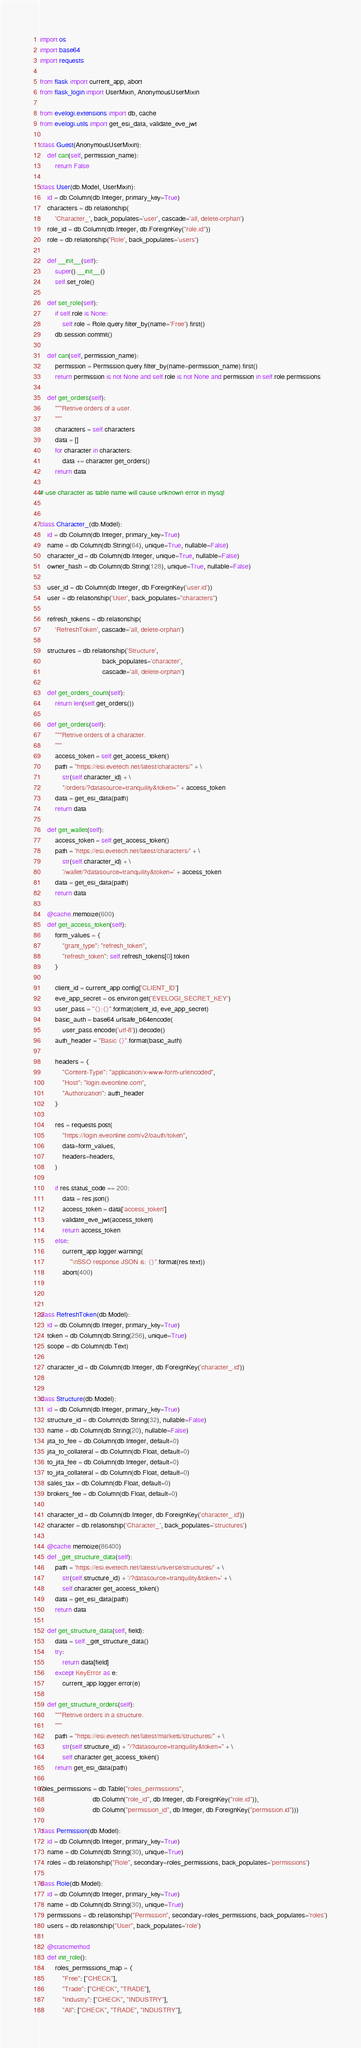Convert code to text. <code><loc_0><loc_0><loc_500><loc_500><_Python_>import os
import base64
import requests

from flask import current_app, abort
from flask_login import UserMixin, AnonymousUserMixin

from evelogi.extensions import db, cache
from evelogi.utils import get_esi_data, validate_eve_jwt

class Guest(AnonymousUserMixin):
    def can(self, permission_name):
        return False

class User(db.Model, UserMixin):
    id = db.Column(db.Integer, primary_key=True)
    characters = db.relationship(
        'Character_', back_populates='user', cascade='all, delete-orphan')
    role_id = db.Column(db.Integer, db.ForeignKey("role.id"))
    role = db.relationship('Role', back_populates='users')

    def __init__(self):
        super().__init__()
        self.set_role()
    
    def set_role(self):
        if self.role is None:
            self.role = Role.query.filter_by(name='Free').first()
        db.session.commit()

    def can(self, permission_name):
        permission = Permission.query.filter_by(name=permission_name).first()
        return permission is not None and self.role is not None and permission in self.role.permissions

    def get_orders(self):
        """Retrive orders of a user.
        """
        characters = self.characters
        data = []
        for character in characters:
            data += character.get_orders()
        return data

# use character as table name will cause unknown error in mysql


class Character_(db.Model):
    id = db.Column(db.Integer, primary_key=True)
    name = db.Column(db.String(64), unique=True, nullable=False)
    character_id = db.Column(db.Integer, unique=True, nullable=False)
    owner_hash = db.Column(db.String(128), unique=True, nullable=False)

    user_id = db.Column(db.Integer, db.ForeignKey('user.id'))
    user = db.relationship('User', back_populates="characters")

    refresh_tokens = db.relationship(
        'RefreshToken', cascade='all, delete-orphan')

    structures = db.relationship('Structure',
                                 back_populates='character',
                                 cascade='all, delete-orphan')

    def get_orders_count(self):
        return len(self.get_orders())

    def get_orders(self):
        """Retrive orders of a character.
        """
        access_token = self.get_access_token()
        path = "https://esi.evetech.net/latest/characters/" + \
            str(self.character_id) + \
            "/orders/?datasource=tranquility&token=" + access_token
        data = get_esi_data(path)
        return data

    def get_wallet(self):
        access_token = self.get_access_token()
        path = 'https://esi.evetech.net/latest/characters/' + \
            str(self.character_id) + \
            '/wallet/?datasource=tranquility&token=' + access_token
        data = get_esi_data(path)
        return data

    @cache.memoize(600)
    def get_access_token(self):
        form_values = {
            "grant_type": "refresh_token",
            "refresh_token": self.refresh_tokens[0].token
        }

        client_id = current_app.config['CLIENT_ID']
        eve_app_secret = os.environ.get('EVELOGI_SECRET_KEY')
        user_pass = "{}:{}".format(client_id, eve_app_secret)
        basic_auth = base64.urlsafe_b64encode(
            user_pass.encode('utf-8')).decode()
        auth_header = "Basic {}".format(basic_auth)

        headers = {
            "Content-Type": "application/x-www-form-urlencoded",
            "Host": "login.eveonline.com",
            "Authorization": auth_header
        }

        res = requests.post(
            "https://login.eveonline.com/v2/oauth/token",
            data=form_values,
            headers=headers,
        )

        if res.status_code == 200:
            data = res.json()
            access_token = data['access_token']
            validate_eve_jwt(access_token)
            return access_token
        else:
            current_app.logger.warning(
                "\nSSO response JSON is: {}".format(res.text))
            abort(400)
            


class RefreshToken(db.Model):
    id = db.Column(db.Integer, primary_key=True)
    token = db.Column(db.String(256), unique=True)
    scope = db.Column(db.Text)

    character_id = db.Column(db.Integer, db.ForeignKey('character_.id'))


class Structure(db.Model):
    id = db.Column(db.Integer, primary_key=True)
    structure_id = db.Column(db.String(32), nullable=False)
    name = db.Column(db.String(20), nullable=False)
    jita_to_fee = db.Column(db.Integer, default=0)
    jita_to_collateral = db.Column(db.Float, default=0)
    to_jita_fee = db.Column(db.Integer, default=0)
    to_jita_collateral = db.Column(db.Float, default=0)
    sales_tax = db.Column(db.Float, default=0)
    brokers_fee = db.Column(db.Float, default=0)

    character_id = db.Column(db.Integer, db.ForeignKey('character_.id'))
    character = db.relationship('Character_', back_populates='structures')

    @cache.memoize(86400)
    def _get_structure_data(self):
        path = 'https://esi.evetech.net/latest/universe/structures/' + \
            str(self.structure_id) + '/?datasource=tranquility&token=' + \
            self.character.get_access_token()
        data = get_esi_data(path)
        return data

    def get_structure_data(self, field):
        data = self._get_structure_data()
        try:
            return data[field]
        except KeyError as e:
            current_app.logger.error(e)

    def get_structure_orders(self):
        """Retrive orders in a structure.
        """
        path = "https://esi.evetech.net/latest/markets/structures/" + \
            str(self.structure_id) + "/?datasource=tranquility&token=" + \
            self.character.get_access_token()
        return get_esi_data(path)

roles_permissions = db.Table("roles_permissions",
                            db.Column("role_id", db.Integer, db.ForeignKey("role.id")),
                            db.Column("permission_id", db.Integer, db.ForeignKey("permission.id")))

class Permission(db.Model):
    id = db.Column(db.Integer, primary_key=True)
    name = db.Column(db.String(30), unique=True)
    roles = db.relationship("Role", secondary=roles_permissions, back_populates='permissions')

class Role(db.Model):
    id = db.Column(db.Integer, primary_key=True)
    name = db.Column(db.String(30), unique=True)
    permissions = db.relationship("Permission", secondary=roles_permissions, back_populates='roles')
    users = db.relationship("User", back_populates='role')

    @staticmethod
    def init_role():
        roles_permissions_map = {
            "Free": ["CHECK"],
            "Trade": ["CHECK", "TRADE"],
            "Industry": ["CHECK", "INDUSTRY"],
            "All": ["CHECK", "TRADE", "INDUSTRY"],</code> 